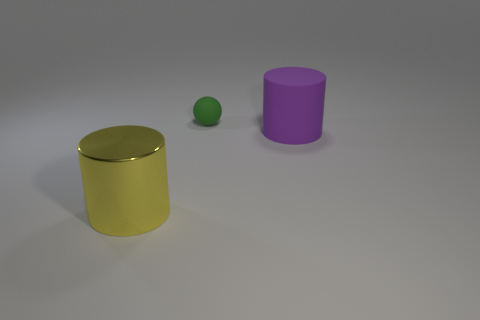Add 1 rubber spheres. How many objects exist? 4 Subtract all yellow cylinders. How many cylinders are left? 1 Subtract 1 spheres. How many spheres are left? 0 Subtract all balls. How many objects are left? 2 Add 2 big yellow metal cylinders. How many big yellow metal cylinders are left? 3 Add 2 large green metallic objects. How many large green metallic objects exist? 2 Subtract 0 gray spheres. How many objects are left? 3 Subtract all blue spheres. Subtract all yellow cubes. How many spheres are left? 1 Subtract all blue balls. Subtract all matte objects. How many objects are left? 1 